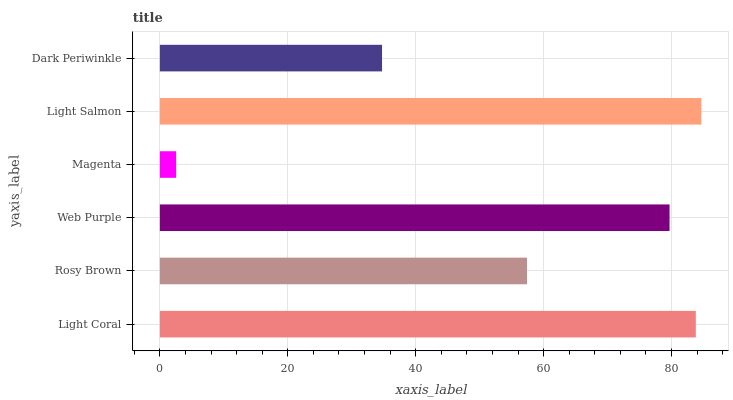Is Magenta the minimum?
Answer yes or no. Yes. Is Light Salmon the maximum?
Answer yes or no. Yes. Is Rosy Brown the minimum?
Answer yes or no. No. Is Rosy Brown the maximum?
Answer yes or no. No. Is Light Coral greater than Rosy Brown?
Answer yes or no. Yes. Is Rosy Brown less than Light Coral?
Answer yes or no. Yes. Is Rosy Brown greater than Light Coral?
Answer yes or no. No. Is Light Coral less than Rosy Brown?
Answer yes or no. No. Is Web Purple the high median?
Answer yes or no. Yes. Is Rosy Brown the low median?
Answer yes or no. Yes. Is Rosy Brown the high median?
Answer yes or no. No. Is Magenta the low median?
Answer yes or no. No. 